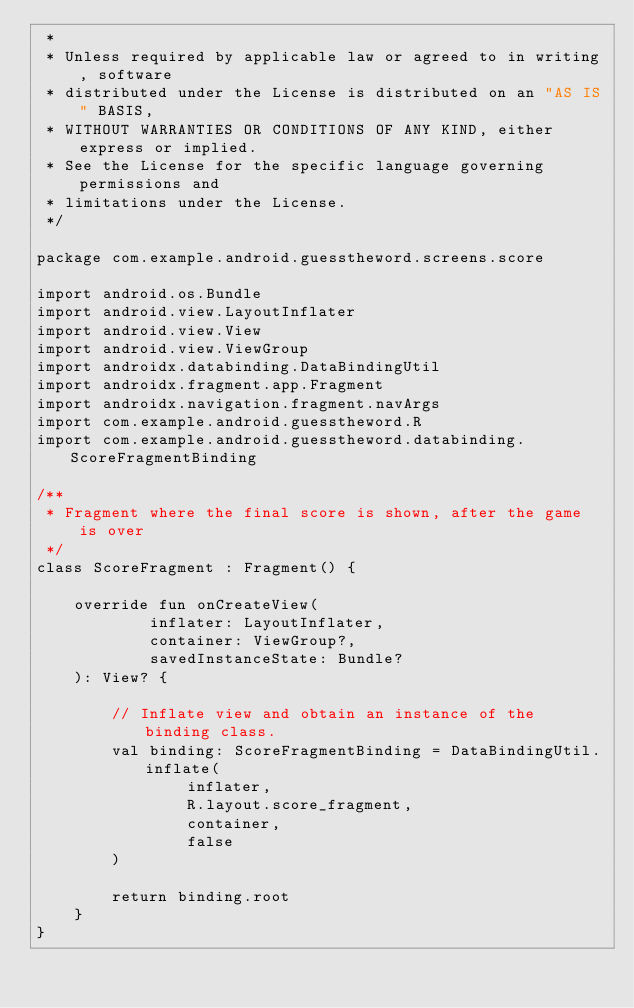Convert code to text. <code><loc_0><loc_0><loc_500><loc_500><_Kotlin_> *
 * Unless required by applicable law or agreed to in writing, software
 * distributed under the License is distributed on an "AS IS" BASIS,
 * WITHOUT WARRANTIES OR CONDITIONS OF ANY KIND, either express or implied.
 * See the License for the specific language governing permissions and
 * limitations under the License.
 */

package com.example.android.guesstheword.screens.score

import android.os.Bundle
import android.view.LayoutInflater
import android.view.View
import android.view.ViewGroup
import androidx.databinding.DataBindingUtil
import androidx.fragment.app.Fragment
import androidx.navigation.fragment.navArgs
import com.example.android.guesstheword.R
import com.example.android.guesstheword.databinding.ScoreFragmentBinding

/**
 * Fragment where the final score is shown, after the game is over
 */
class ScoreFragment : Fragment() {

    override fun onCreateView(
            inflater: LayoutInflater,
            container: ViewGroup?,
            savedInstanceState: Bundle?
    ): View? {

        // Inflate view and obtain an instance of the binding class.
        val binding: ScoreFragmentBinding = DataBindingUtil.inflate(
                inflater,
                R.layout.score_fragment,
                container,
                false
        )

        return binding.root
    }
}
</code> 